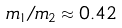<formula> <loc_0><loc_0><loc_500><loc_500>m _ { 1 } / m _ { 2 } \approx 0 . 4 2</formula> 